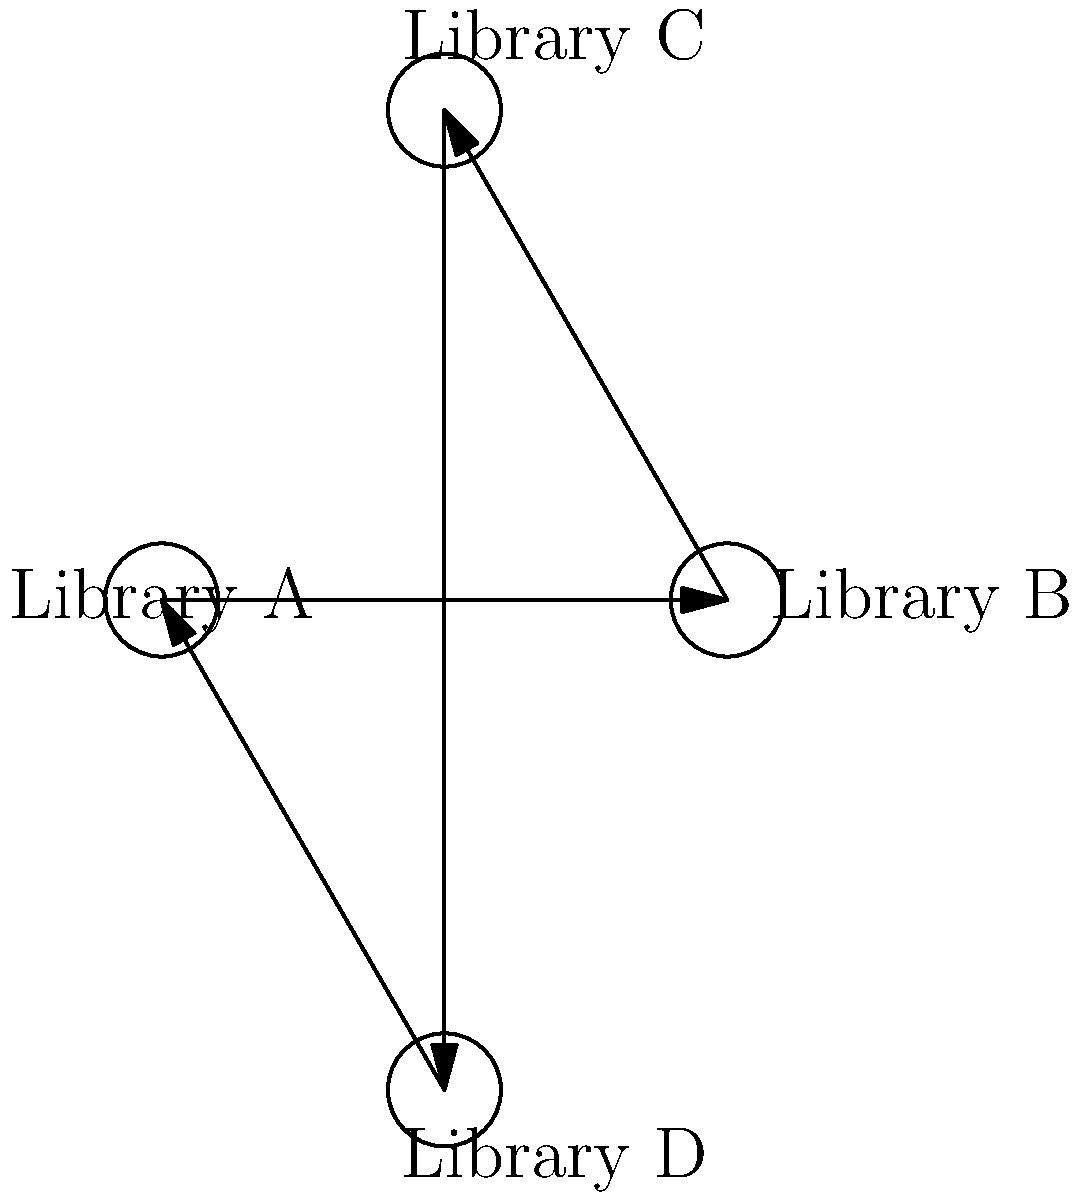In a network of four libraries sharing translated book catalogs, data flows in a unidirectional cycle. If Library A initiates a catalog update, how many transmissions are required for the update to reach all libraries and return to Library A? To solve this problem, we need to follow the data flow in the network:

1. Library A initiates the catalog update. This is the starting point.

2. The update flows from Library A to Library B. This is the first transmission.

3. From Library B, it flows to Library C. This is the second transmission.

4. The update then moves from Library C to Library D. This is the third transmission.

5. Finally, the update returns from Library D to Library A, completing the cycle. This is the fourth transmission.

Each step in this process represents one transmission of the catalog update. We count the number of transmissions required for the update to reach all libraries and return to the starting point.

The total number of transmissions is equal to the number of libraries in the network, which is 4 in this case.
Answer: 4 transmissions 